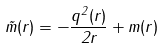<formula> <loc_0><loc_0><loc_500><loc_500>\tilde { m } ( r ) = - \frac { q ^ { 2 } ( r ) } { 2 r } + m ( r )</formula> 